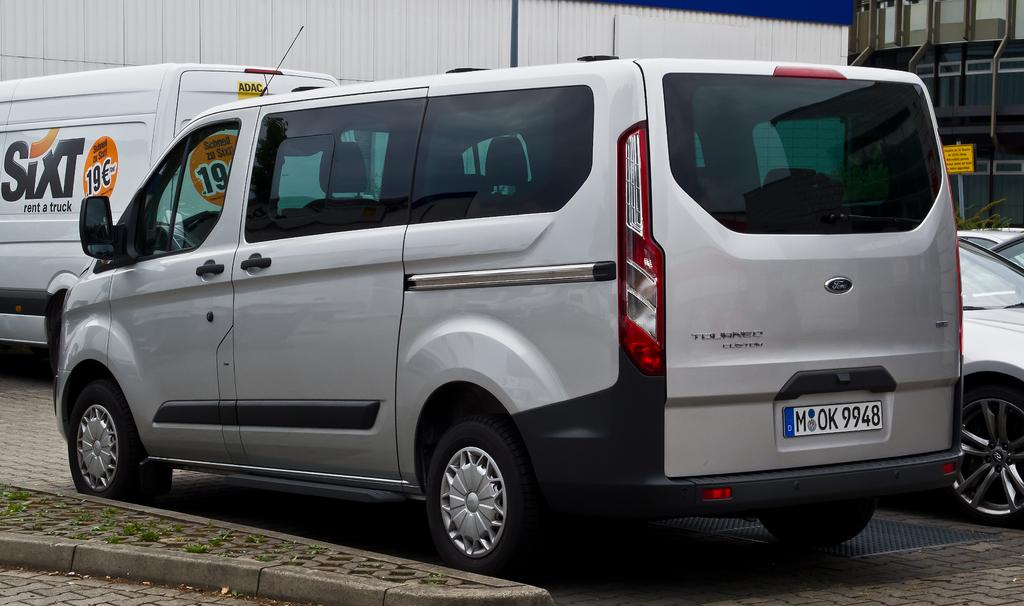<image>
Give a short and clear explanation of the subsequent image. A light colored van with the license plate M OK9948 is parked next to another car in a lot. 